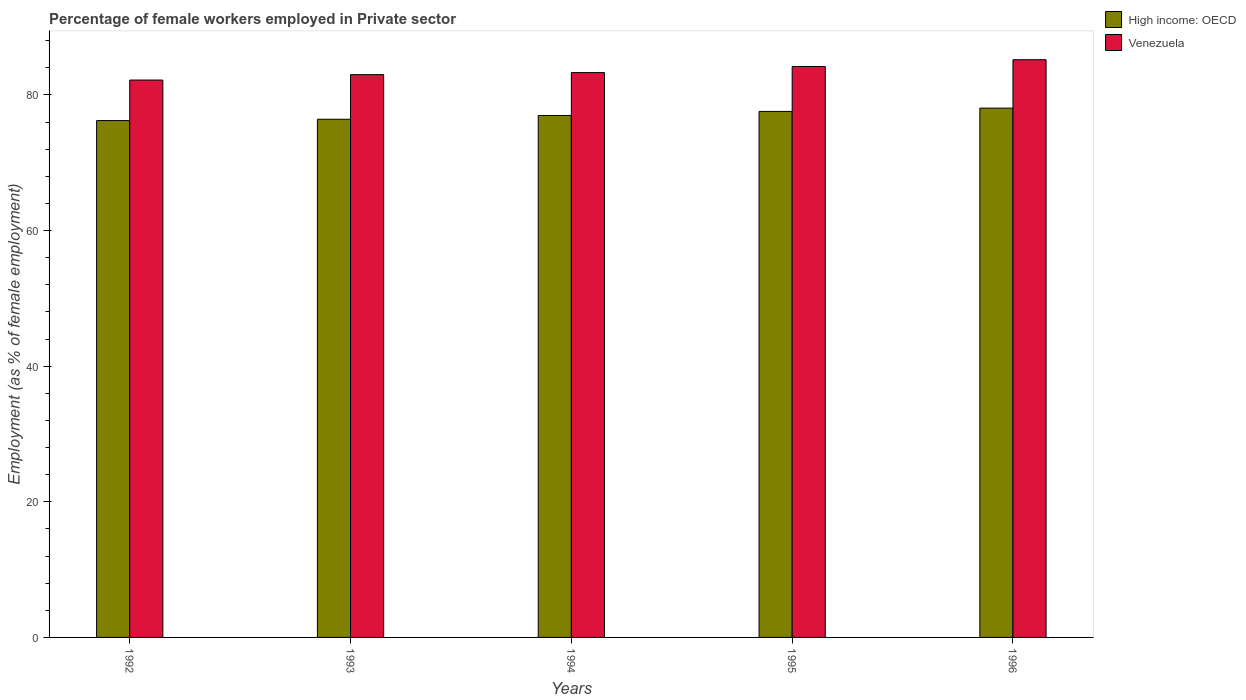How many groups of bars are there?
Offer a very short reply. 5. How many bars are there on the 4th tick from the left?
Keep it short and to the point. 2. How many bars are there on the 3rd tick from the right?
Keep it short and to the point. 2. In how many cases, is the number of bars for a given year not equal to the number of legend labels?
Offer a terse response. 0. What is the percentage of females employed in Private sector in High income: OECD in 1993?
Provide a short and direct response. 76.42. Across all years, what is the maximum percentage of females employed in Private sector in High income: OECD?
Provide a short and direct response. 78.06. Across all years, what is the minimum percentage of females employed in Private sector in High income: OECD?
Ensure brevity in your answer.  76.23. In which year was the percentage of females employed in Private sector in Venezuela minimum?
Provide a succinct answer. 1992. What is the total percentage of females employed in Private sector in Venezuela in the graph?
Ensure brevity in your answer.  417.9. What is the difference between the percentage of females employed in Private sector in Venezuela in 1993 and that in 1995?
Ensure brevity in your answer.  -1.2. What is the difference between the percentage of females employed in Private sector in High income: OECD in 1992 and the percentage of females employed in Private sector in Venezuela in 1993?
Your answer should be very brief. -6.77. What is the average percentage of females employed in Private sector in Venezuela per year?
Your answer should be very brief. 83.58. In the year 1994, what is the difference between the percentage of females employed in Private sector in Venezuela and percentage of females employed in Private sector in High income: OECD?
Provide a succinct answer. 6.32. In how many years, is the percentage of females employed in Private sector in High income: OECD greater than 76 %?
Your response must be concise. 5. What is the ratio of the percentage of females employed in Private sector in Venezuela in 1992 to that in 1996?
Offer a very short reply. 0.96. Is the percentage of females employed in Private sector in Venezuela in 1994 less than that in 1995?
Offer a very short reply. Yes. Is the difference between the percentage of females employed in Private sector in Venezuela in 1993 and 1994 greater than the difference between the percentage of females employed in Private sector in High income: OECD in 1993 and 1994?
Keep it short and to the point. Yes. What is the difference between the highest and the second highest percentage of females employed in Private sector in High income: OECD?
Offer a very short reply. 0.49. What is the difference between the highest and the lowest percentage of females employed in Private sector in Venezuela?
Your answer should be compact. 3. What does the 2nd bar from the left in 1996 represents?
Offer a very short reply. Venezuela. What does the 1st bar from the right in 1994 represents?
Give a very brief answer. Venezuela. How many years are there in the graph?
Make the answer very short. 5. Are the values on the major ticks of Y-axis written in scientific E-notation?
Ensure brevity in your answer.  No. Does the graph contain any zero values?
Keep it short and to the point. No. Does the graph contain grids?
Make the answer very short. No. Where does the legend appear in the graph?
Offer a very short reply. Top right. How many legend labels are there?
Offer a very short reply. 2. What is the title of the graph?
Provide a succinct answer. Percentage of female workers employed in Private sector. Does "Jamaica" appear as one of the legend labels in the graph?
Offer a very short reply. No. What is the label or title of the X-axis?
Your answer should be very brief. Years. What is the label or title of the Y-axis?
Give a very brief answer. Employment (as % of female employment). What is the Employment (as % of female employment) of High income: OECD in 1992?
Offer a very short reply. 76.23. What is the Employment (as % of female employment) of Venezuela in 1992?
Provide a succinct answer. 82.2. What is the Employment (as % of female employment) in High income: OECD in 1993?
Your answer should be compact. 76.42. What is the Employment (as % of female employment) in High income: OECD in 1994?
Keep it short and to the point. 76.98. What is the Employment (as % of female employment) in Venezuela in 1994?
Give a very brief answer. 83.3. What is the Employment (as % of female employment) in High income: OECD in 1995?
Keep it short and to the point. 77.57. What is the Employment (as % of female employment) in Venezuela in 1995?
Your answer should be very brief. 84.2. What is the Employment (as % of female employment) of High income: OECD in 1996?
Your answer should be very brief. 78.06. What is the Employment (as % of female employment) of Venezuela in 1996?
Offer a terse response. 85.2. Across all years, what is the maximum Employment (as % of female employment) of High income: OECD?
Your answer should be compact. 78.06. Across all years, what is the maximum Employment (as % of female employment) of Venezuela?
Your response must be concise. 85.2. Across all years, what is the minimum Employment (as % of female employment) in High income: OECD?
Your answer should be very brief. 76.23. Across all years, what is the minimum Employment (as % of female employment) of Venezuela?
Make the answer very short. 82.2. What is the total Employment (as % of female employment) of High income: OECD in the graph?
Give a very brief answer. 385.26. What is the total Employment (as % of female employment) in Venezuela in the graph?
Give a very brief answer. 417.9. What is the difference between the Employment (as % of female employment) of High income: OECD in 1992 and that in 1993?
Give a very brief answer. -0.19. What is the difference between the Employment (as % of female employment) in High income: OECD in 1992 and that in 1994?
Provide a succinct answer. -0.75. What is the difference between the Employment (as % of female employment) of Venezuela in 1992 and that in 1994?
Give a very brief answer. -1.1. What is the difference between the Employment (as % of female employment) of High income: OECD in 1992 and that in 1995?
Your answer should be compact. -1.35. What is the difference between the Employment (as % of female employment) of Venezuela in 1992 and that in 1995?
Provide a succinct answer. -2. What is the difference between the Employment (as % of female employment) of High income: OECD in 1992 and that in 1996?
Keep it short and to the point. -1.84. What is the difference between the Employment (as % of female employment) of High income: OECD in 1993 and that in 1994?
Provide a short and direct response. -0.56. What is the difference between the Employment (as % of female employment) of High income: OECD in 1993 and that in 1995?
Your answer should be very brief. -1.16. What is the difference between the Employment (as % of female employment) of High income: OECD in 1993 and that in 1996?
Provide a short and direct response. -1.64. What is the difference between the Employment (as % of female employment) of Venezuela in 1993 and that in 1996?
Keep it short and to the point. -2.2. What is the difference between the Employment (as % of female employment) of High income: OECD in 1994 and that in 1995?
Ensure brevity in your answer.  -0.6. What is the difference between the Employment (as % of female employment) of High income: OECD in 1994 and that in 1996?
Make the answer very short. -1.08. What is the difference between the Employment (as % of female employment) of Venezuela in 1994 and that in 1996?
Your answer should be compact. -1.9. What is the difference between the Employment (as % of female employment) of High income: OECD in 1995 and that in 1996?
Your answer should be compact. -0.49. What is the difference between the Employment (as % of female employment) of High income: OECD in 1992 and the Employment (as % of female employment) of Venezuela in 1993?
Offer a very short reply. -6.77. What is the difference between the Employment (as % of female employment) of High income: OECD in 1992 and the Employment (as % of female employment) of Venezuela in 1994?
Your response must be concise. -7.07. What is the difference between the Employment (as % of female employment) in High income: OECD in 1992 and the Employment (as % of female employment) in Venezuela in 1995?
Give a very brief answer. -7.97. What is the difference between the Employment (as % of female employment) in High income: OECD in 1992 and the Employment (as % of female employment) in Venezuela in 1996?
Give a very brief answer. -8.97. What is the difference between the Employment (as % of female employment) in High income: OECD in 1993 and the Employment (as % of female employment) in Venezuela in 1994?
Your answer should be very brief. -6.88. What is the difference between the Employment (as % of female employment) in High income: OECD in 1993 and the Employment (as % of female employment) in Venezuela in 1995?
Provide a short and direct response. -7.78. What is the difference between the Employment (as % of female employment) of High income: OECD in 1993 and the Employment (as % of female employment) of Venezuela in 1996?
Provide a succinct answer. -8.78. What is the difference between the Employment (as % of female employment) of High income: OECD in 1994 and the Employment (as % of female employment) of Venezuela in 1995?
Keep it short and to the point. -7.22. What is the difference between the Employment (as % of female employment) in High income: OECD in 1994 and the Employment (as % of female employment) in Venezuela in 1996?
Your response must be concise. -8.22. What is the difference between the Employment (as % of female employment) in High income: OECD in 1995 and the Employment (as % of female employment) in Venezuela in 1996?
Give a very brief answer. -7.63. What is the average Employment (as % of female employment) in High income: OECD per year?
Make the answer very short. 77.05. What is the average Employment (as % of female employment) in Venezuela per year?
Ensure brevity in your answer.  83.58. In the year 1992, what is the difference between the Employment (as % of female employment) of High income: OECD and Employment (as % of female employment) of Venezuela?
Provide a succinct answer. -5.97. In the year 1993, what is the difference between the Employment (as % of female employment) in High income: OECD and Employment (as % of female employment) in Venezuela?
Offer a terse response. -6.58. In the year 1994, what is the difference between the Employment (as % of female employment) in High income: OECD and Employment (as % of female employment) in Venezuela?
Ensure brevity in your answer.  -6.32. In the year 1995, what is the difference between the Employment (as % of female employment) in High income: OECD and Employment (as % of female employment) in Venezuela?
Your answer should be very brief. -6.63. In the year 1996, what is the difference between the Employment (as % of female employment) in High income: OECD and Employment (as % of female employment) in Venezuela?
Keep it short and to the point. -7.14. What is the ratio of the Employment (as % of female employment) in High income: OECD in 1992 to that in 1993?
Make the answer very short. 1. What is the ratio of the Employment (as % of female employment) of High income: OECD in 1992 to that in 1994?
Offer a very short reply. 0.99. What is the ratio of the Employment (as % of female employment) in Venezuela in 1992 to that in 1994?
Your answer should be compact. 0.99. What is the ratio of the Employment (as % of female employment) in High income: OECD in 1992 to that in 1995?
Your answer should be very brief. 0.98. What is the ratio of the Employment (as % of female employment) in Venezuela in 1992 to that in 1995?
Your answer should be very brief. 0.98. What is the ratio of the Employment (as % of female employment) of High income: OECD in 1992 to that in 1996?
Offer a terse response. 0.98. What is the ratio of the Employment (as % of female employment) of Venezuela in 1992 to that in 1996?
Your response must be concise. 0.96. What is the ratio of the Employment (as % of female employment) in High income: OECD in 1993 to that in 1994?
Your answer should be compact. 0.99. What is the ratio of the Employment (as % of female employment) in High income: OECD in 1993 to that in 1995?
Ensure brevity in your answer.  0.99. What is the ratio of the Employment (as % of female employment) in Venezuela in 1993 to that in 1995?
Your answer should be very brief. 0.99. What is the ratio of the Employment (as % of female employment) in High income: OECD in 1993 to that in 1996?
Offer a terse response. 0.98. What is the ratio of the Employment (as % of female employment) in Venezuela in 1993 to that in 1996?
Ensure brevity in your answer.  0.97. What is the ratio of the Employment (as % of female employment) in High income: OECD in 1994 to that in 1995?
Provide a succinct answer. 0.99. What is the ratio of the Employment (as % of female employment) in Venezuela in 1994 to that in 1995?
Offer a very short reply. 0.99. What is the ratio of the Employment (as % of female employment) of High income: OECD in 1994 to that in 1996?
Offer a very short reply. 0.99. What is the ratio of the Employment (as % of female employment) in Venezuela in 1994 to that in 1996?
Provide a short and direct response. 0.98. What is the ratio of the Employment (as % of female employment) in High income: OECD in 1995 to that in 1996?
Make the answer very short. 0.99. What is the ratio of the Employment (as % of female employment) of Venezuela in 1995 to that in 1996?
Your response must be concise. 0.99. What is the difference between the highest and the second highest Employment (as % of female employment) in High income: OECD?
Your response must be concise. 0.49. What is the difference between the highest and the second highest Employment (as % of female employment) of Venezuela?
Offer a very short reply. 1. What is the difference between the highest and the lowest Employment (as % of female employment) of High income: OECD?
Keep it short and to the point. 1.84. 